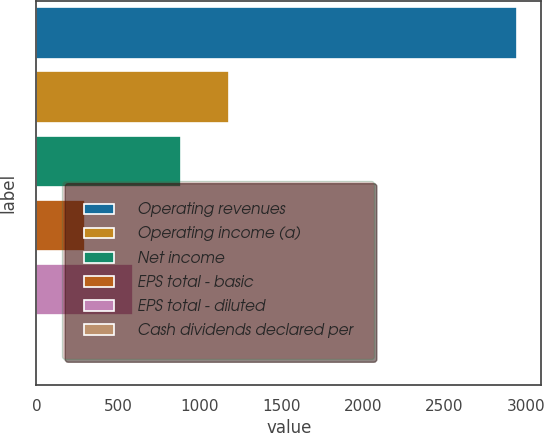Convert chart. <chart><loc_0><loc_0><loc_500><loc_500><bar_chart><fcel>Operating revenues<fcel>Operating income (a)<fcel>Net income<fcel>EPS total - basic<fcel>EPS total - diluted<fcel>Cash dividends declared per<nl><fcel>2946<fcel>1178.6<fcel>884.04<fcel>294.92<fcel>589.48<fcel>0.36<nl></chart> 